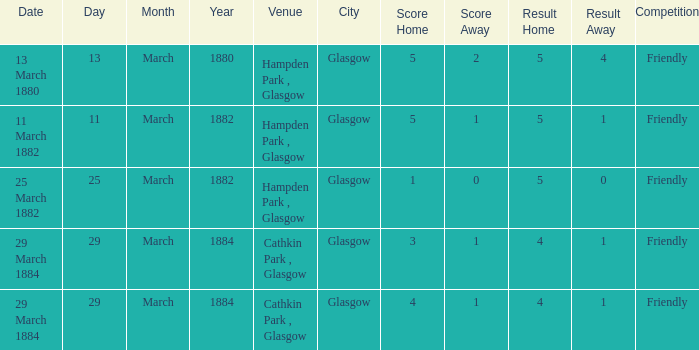Which item resulted in a score of 4-1? 3-1, 4-1. 